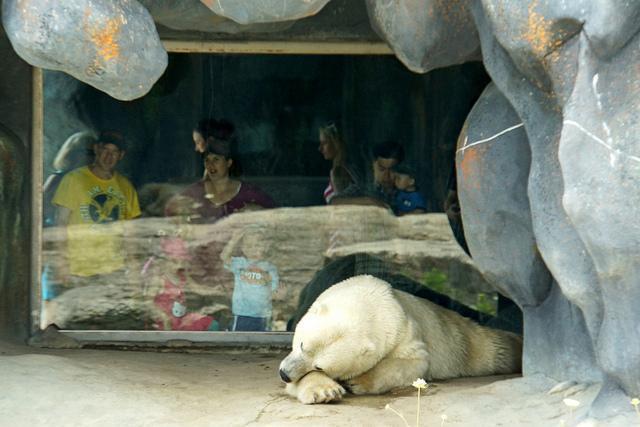How many people are in the photo?
Give a very brief answer. 6. 